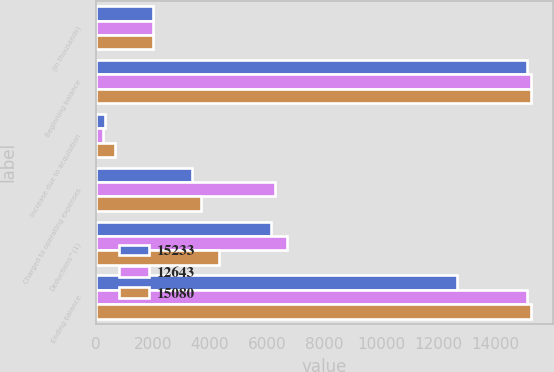Convert chart. <chart><loc_0><loc_0><loc_500><loc_500><stacked_bar_chart><ecel><fcel>(in thousands)<fcel>Beginning balance<fcel>Increase due to acquisition<fcel>Charged to operating expenses<fcel>Deductions^(1)<fcel>Ending balance<nl><fcel>15233<fcel>2012<fcel>15080<fcel>325<fcel>3356<fcel>6118<fcel>12643<nl><fcel>12643<fcel>2011<fcel>15233<fcel>269<fcel>6271<fcel>6693<fcel>15080<nl><fcel>15080<fcel>2010<fcel>15225<fcel>662<fcel>3673<fcel>4327<fcel>15233<nl></chart> 